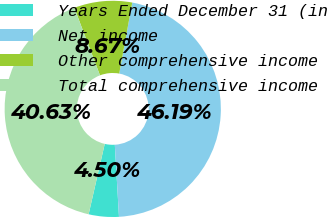Convert chart. <chart><loc_0><loc_0><loc_500><loc_500><pie_chart><fcel>Years Ended December 31 (in<fcel>Net income<fcel>Other comprehensive income<fcel>Total comprehensive income<nl><fcel>4.5%<fcel>46.19%<fcel>8.67%<fcel>40.63%<nl></chart> 